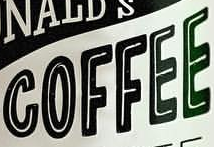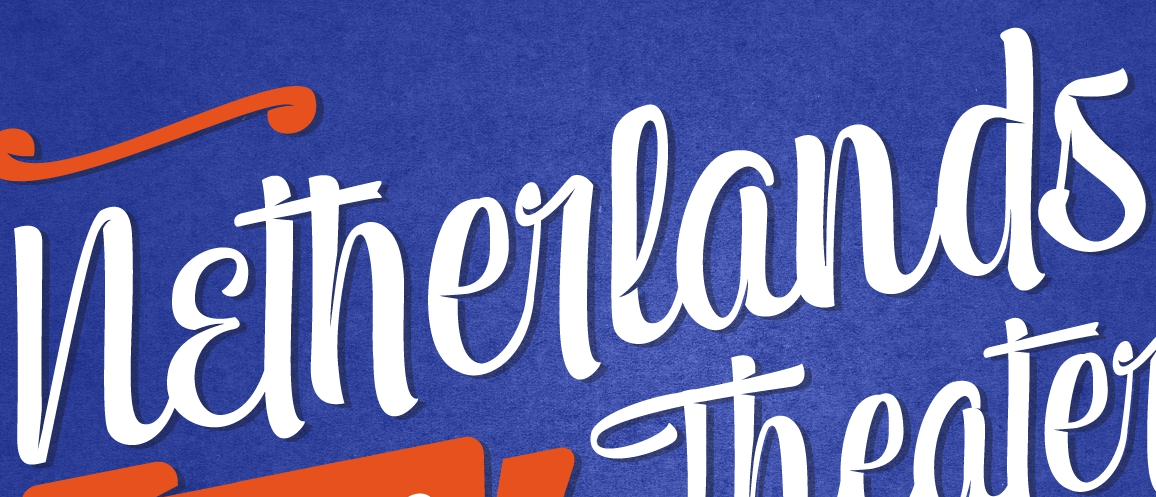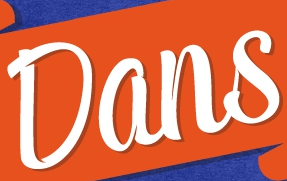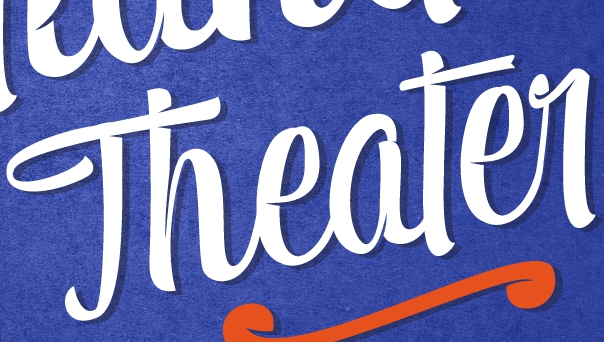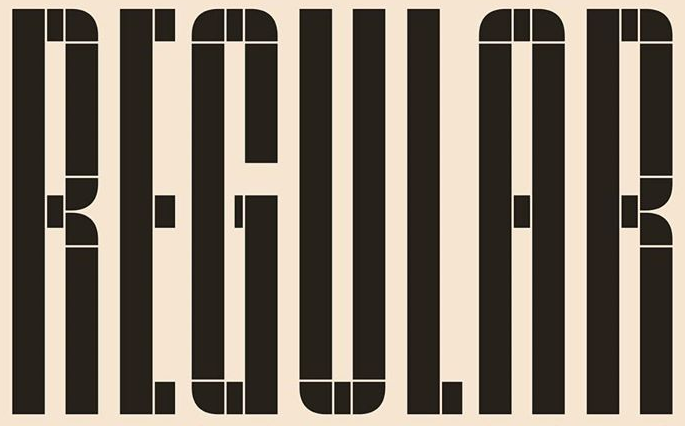Identify the words shown in these images in order, separated by a semicolon. COFFEE; Netherlands; Dans; Theater; REGULAR 